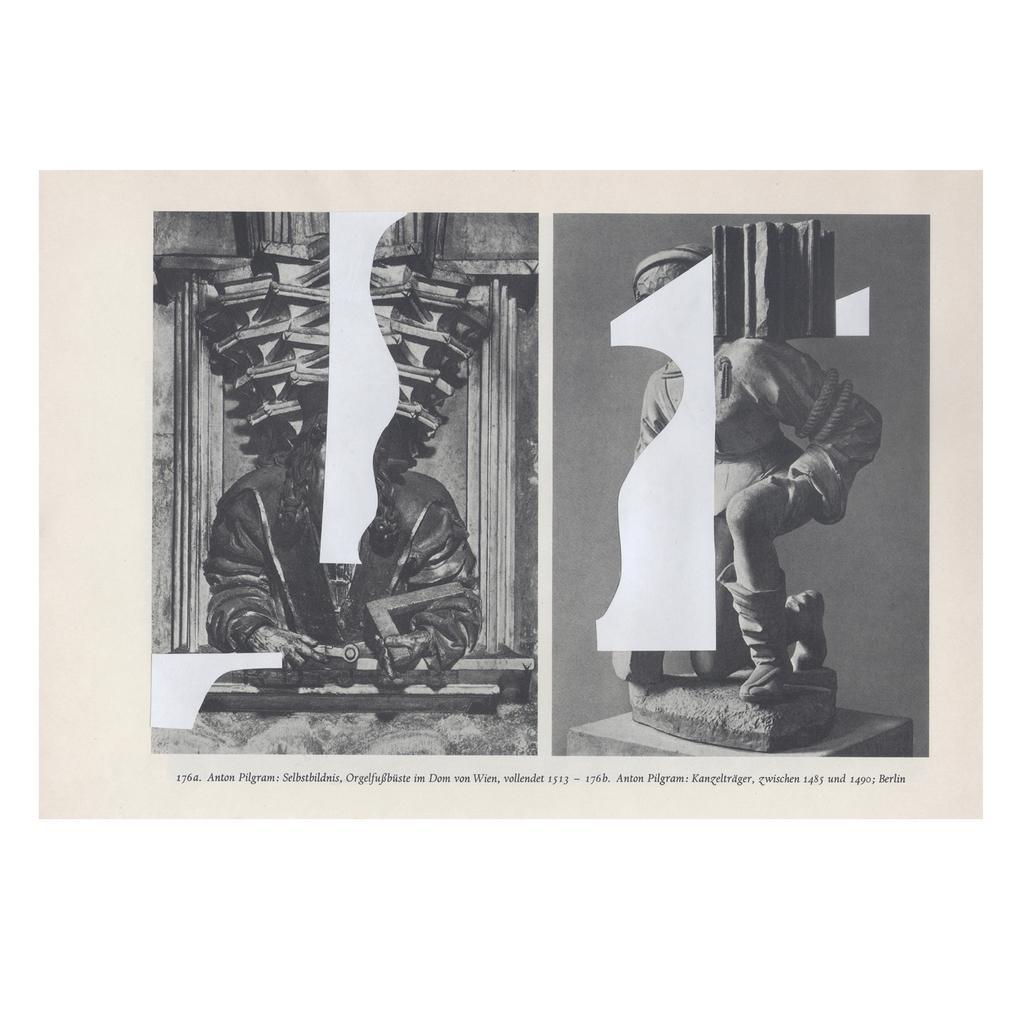Could you give a brief overview of what you see in this image? This is a poster and in this poster we can see a statue of a person and aside to this statue we can see a person. 